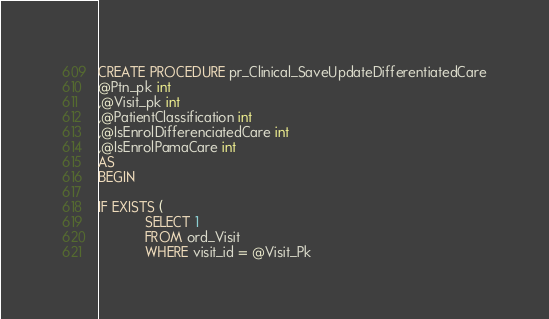Convert code to text. <code><loc_0><loc_0><loc_500><loc_500><_SQL_>

CREATE PROCEDURE pr_Clinical_SaveUpdateDifferentiatedCare
@Ptn_pk int
,@Visit_pk int
,@PatientClassification int
,@IsEnrolDifferenciatedCare int
,@IsEnrolPamaCare int 
AS
BEGIN

IF EXISTS (
			SELECT 1
			FROM ord_Visit
			WHERE visit_id = @Visit_Pk</code> 